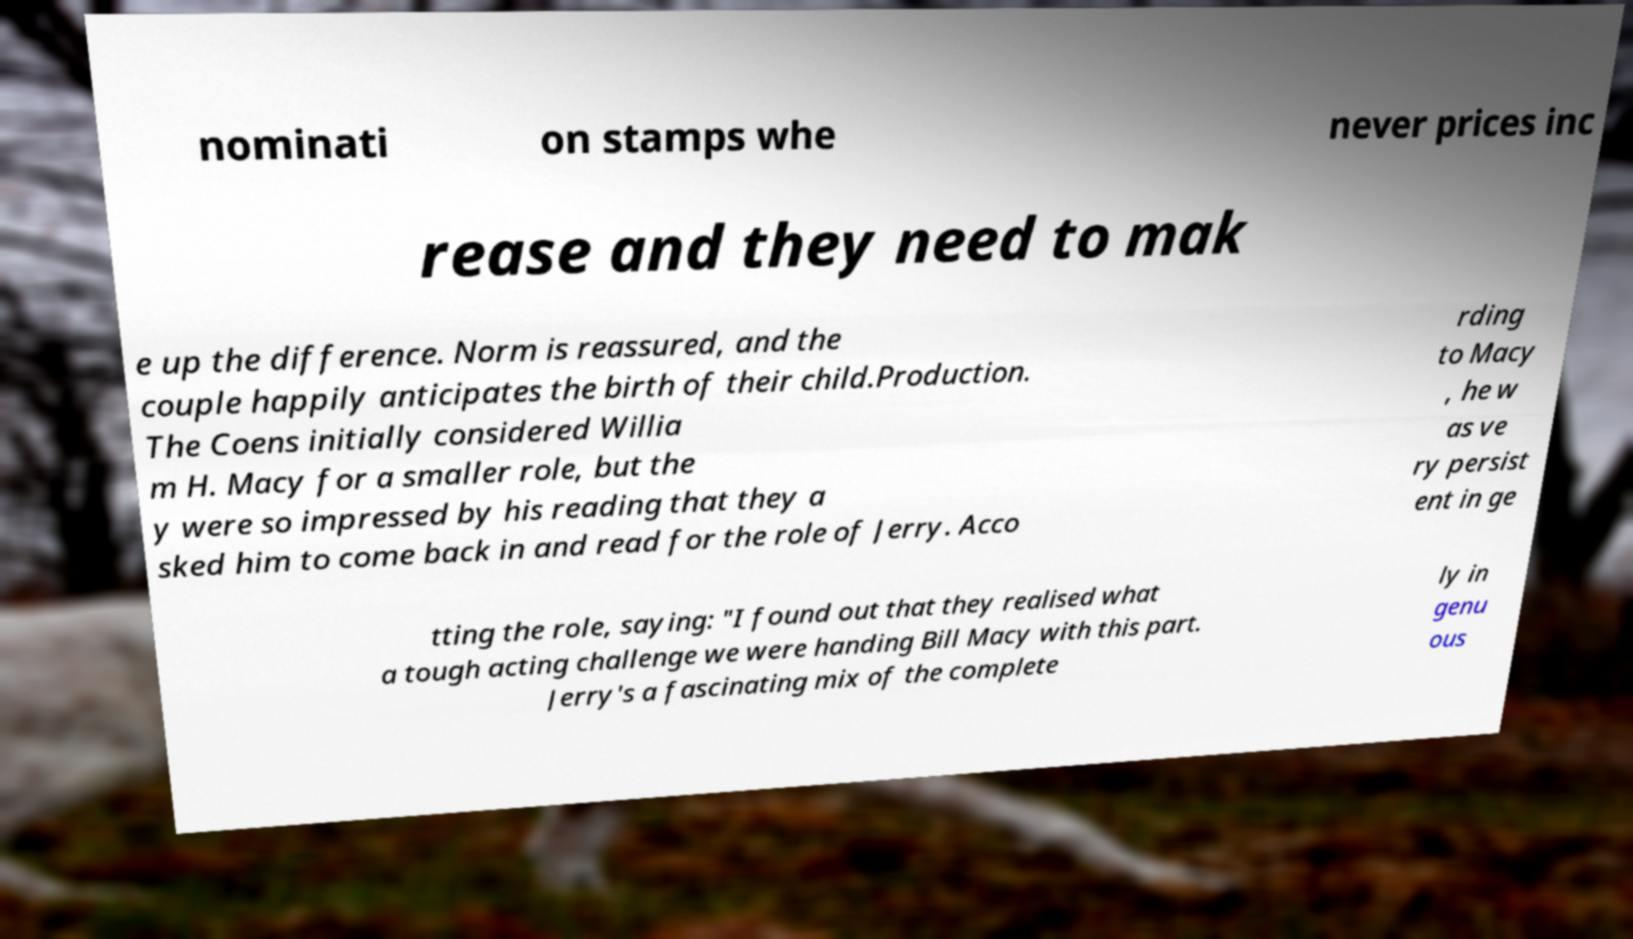Could you assist in decoding the text presented in this image and type it out clearly? nominati on stamps whe never prices inc rease and they need to mak e up the difference. Norm is reassured, and the couple happily anticipates the birth of their child.Production. The Coens initially considered Willia m H. Macy for a smaller role, but the y were so impressed by his reading that they a sked him to come back in and read for the role of Jerry. Acco rding to Macy , he w as ve ry persist ent in ge tting the role, saying: "I found out that they realised what a tough acting challenge we were handing Bill Macy with this part. Jerry's a fascinating mix of the complete ly in genu ous 